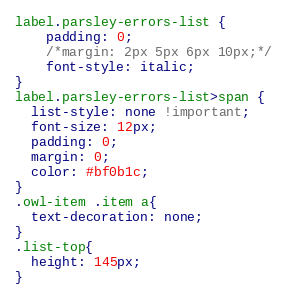Convert code to text. <code><loc_0><loc_0><loc_500><loc_500><_CSS_>label.parsley-errors-list {
    padding: 0;
    /*margin: 2px 5px 6px 10px;*/
    font-style: italic;
}
label.parsley-errors-list>span {
  list-style: none !important;
  font-size: 12px;
  padding: 0;
  margin: 0;
  color: #bf0b1c;
}
.owl-item .item a{
  text-decoration: none;
}
.list-top{
  height: 145px;
}</code> 